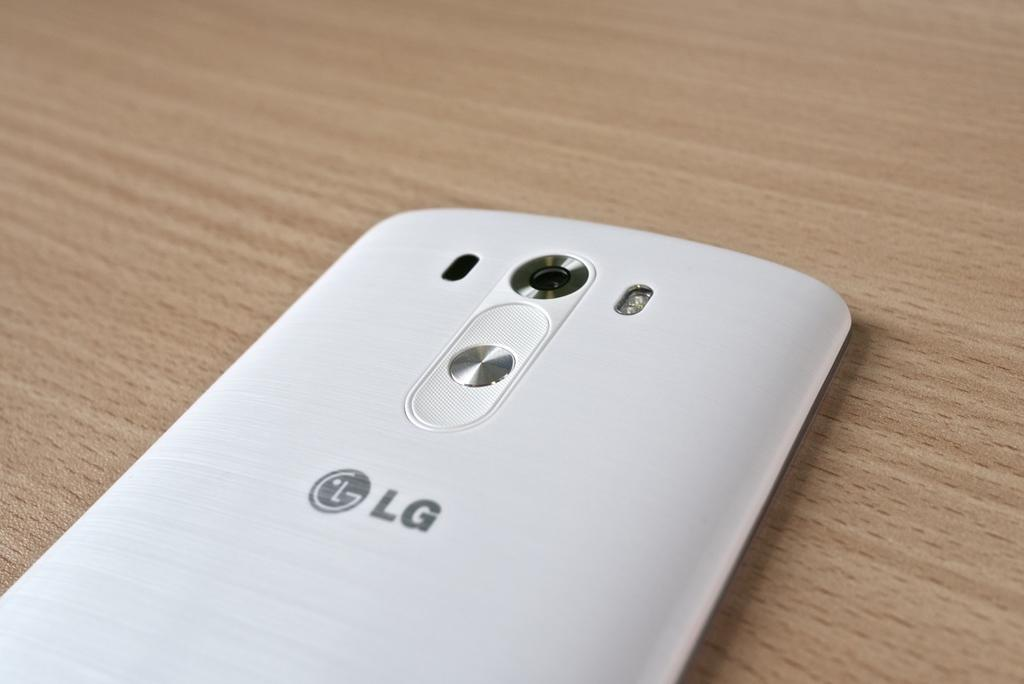<image>
Share a concise interpretation of the image provided. An LG white phone is placed on a table 